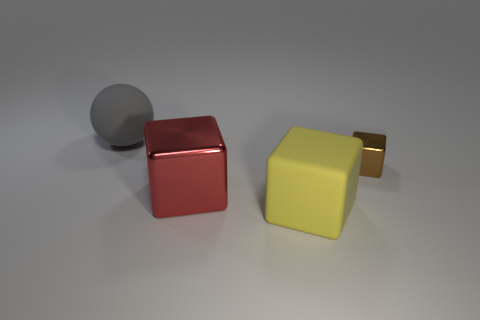Do the shiny block that is in front of the tiny brown block and the thing that is to the right of the yellow cube have the same size?
Your answer should be compact. No. Is there any other thing that has the same shape as the gray object?
Ensure brevity in your answer.  No. What number of objects are large objects that are in front of the gray matte ball or big spheres?
Give a very brief answer. 3. How many blocks are to the right of the big rubber thing in front of the metallic thing that is on the right side of the large rubber cube?
Make the answer very short. 1. Is there anything else that is the same size as the brown metal cube?
Ensure brevity in your answer.  No. The thing on the right side of the matte thing that is right of the big matte thing that is behind the tiny metal block is what shape?
Provide a short and direct response. Cube. How many other objects are there of the same color as the tiny metal thing?
Your answer should be compact. 0. The large rubber object left of the big matte thing right of the matte ball is what shape?
Ensure brevity in your answer.  Sphere. There is a big gray matte ball; what number of blocks are in front of it?
Provide a succinct answer. 3. Is there a brown block made of the same material as the red object?
Keep it short and to the point. Yes. 